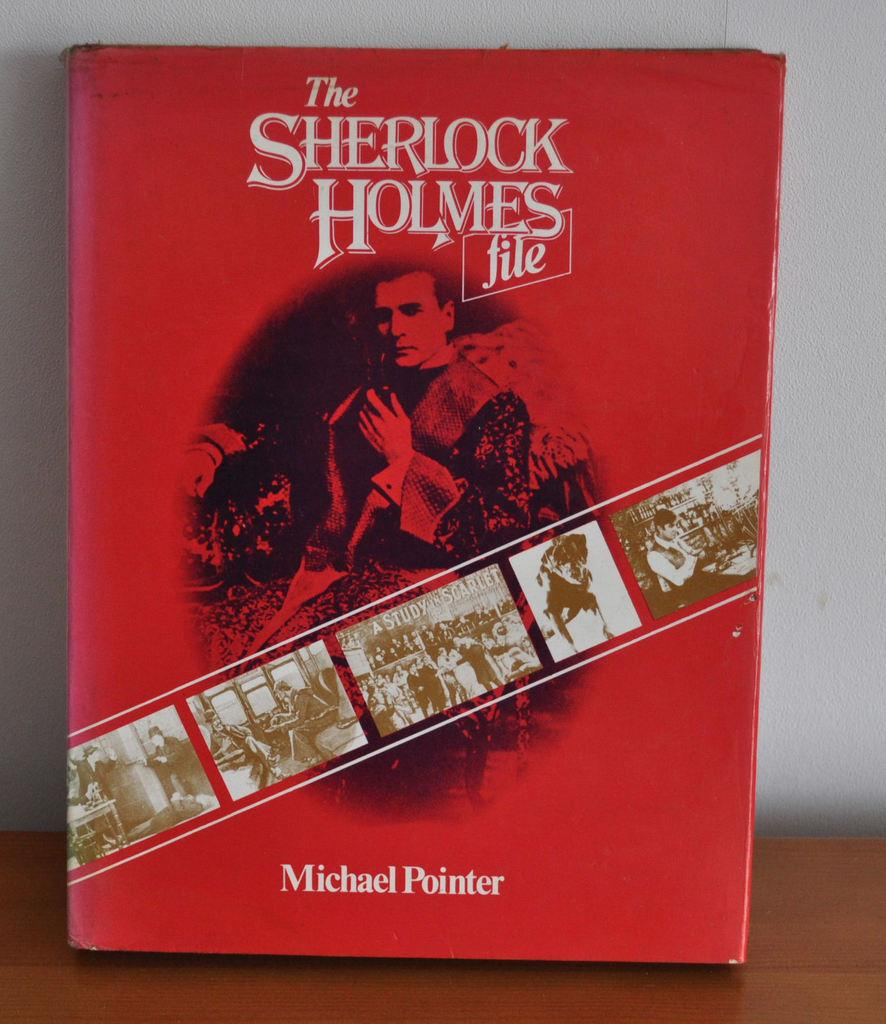<image>
Share a concise interpretation of the image provided. A book about Sherlock Holmes by Michael Pointer. 